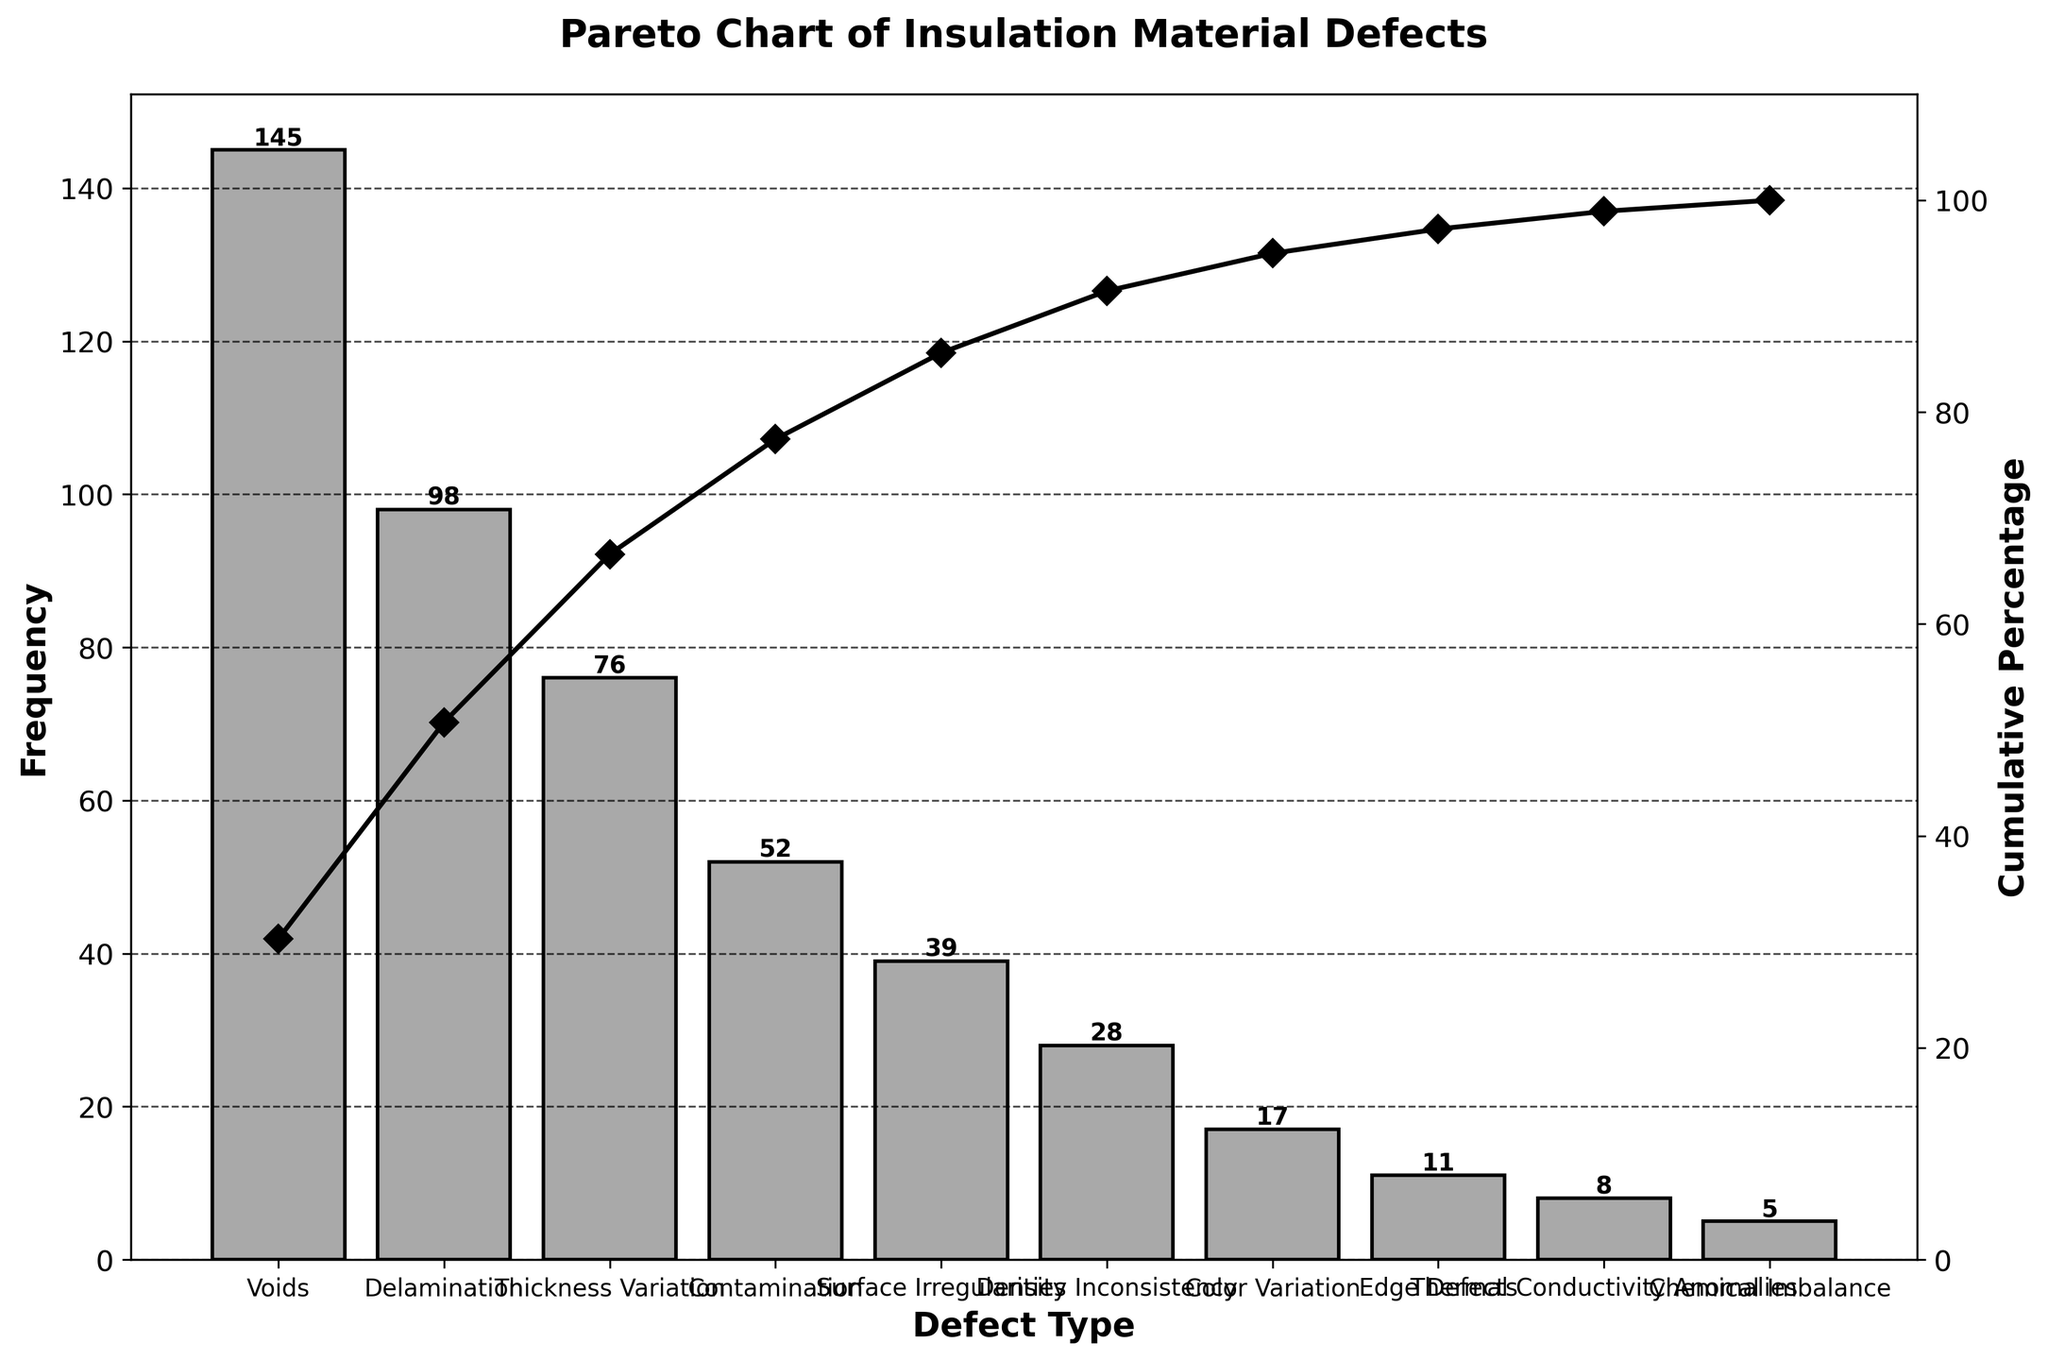What is the most frequent defect in insulation material production? The bar with the highest frequency represents the most frequent defect. In the figure, the highest bar corresponds to "Voids" with a frequency of 145.
Answer: Voids What is the cumulative percentage of the top three defects? To find this, sum the cumulative percentages of the first three bars. According to the figure, the cumulative percentages for "Voids," "Delamination," and "Thickness Variation" are approximately 28.2%, 47.3%, and 62.6%, respectively. Summing these percentages gives approximately 138.1%.
Answer: 138.1% Which defect has the lowest frequency? The shortest bar represents the defect with the lowest frequency. The figure shows that "Chemical Imbalance" has the shortest bar with a frequency of 5.
Answer: Chemical Imbalance How many defect types have a frequency greater than 50? Count the number of bars with heights greater than 50. According to the figure, four defect types have frequencies greater than 50: "Voids," "Delamination," "Thickness Variation," and "Contamination."
Answer: Four What is the percentage difference in cumulative percentage between "Contamination" and "Color Variation"? First, find the cumulative percentages for "Contamination" and "Color Variation" from the figure. The cumulative percentages are approximately 75.9% and 88.3%, respectively. The percentage difference is 88.3% - 75.9% = 12.4%.
Answer: 12.4% Is the cumulative percentage above 90% after considering "Edge Defects"? Check the cumulative percentage at "Edge Defects." The figure indicates that the cumulative percentage at "Edge Defects" is approximately 96.5%, which is above 90%.
Answer: Yes What is the total frequency of defects categorized as "Density Inconsistency" and "Color Variation"? Sum the frequencies of "Density Inconsistency" (28) and "Color Variation" (17). So, 28 + 17 = 45.
Answer: 45 Which has a higher frequency: "Surface Irregularities" or "Edge Defects"? Compare the heights of the bars for "Surface Irregularities" and "Edge Defects." The figure shows that "Surface Irregularities" have a frequency of 39, which is higher than "Edge Defects" with a frequency of 11.
Answer: Surface Irregularities What is the total frequency of all defect types? Sum the frequencies of all defect types. Adding the values: 145 + 98 + 76 + 52 + 39 + 28 + 17 + 11 + 8 + 5 = 479.
Answer: 479 What percentage of the total defects does "Thickness Variation" represent? To find this, divide the frequency of "Thickness Variation" (76) by the total frequency (479) and multiply by 100. So, (76 / 479) * 100 ≈ 15.9%.
Answer: 15.9% 